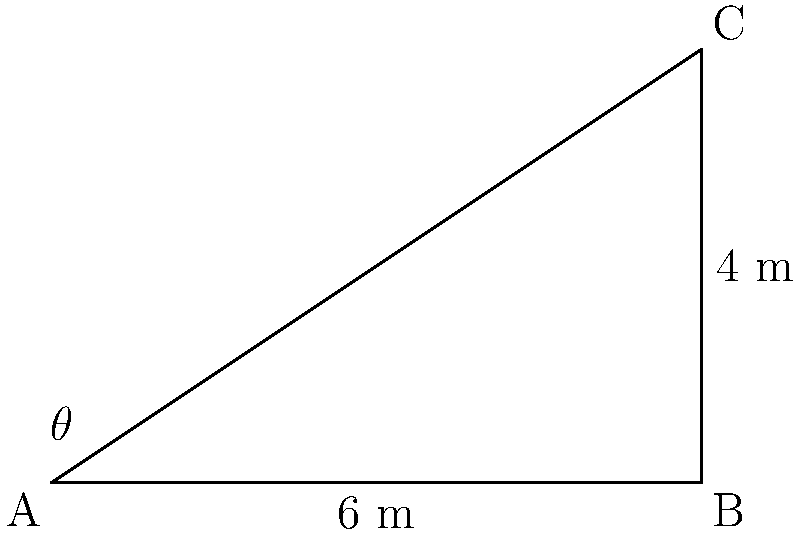At the Lassiter's complex, we're planning a new triangular garden area. The garden will be right-angled, with one side along the hotel wall measuring 6 meters, and another side along the lake shore measuring 4 meters. Using this information, calculate the area of the new garden space. Round your answer to the nearest square meter. Let's approach this step-by-step using trigonometry:

1) We have a right-angled triangle with two known sides:
   - The base (along the hotel wall) is 6 meters
   - The height (along the lake shore) is 4 meters

2) To find the area of a triangle, we use the formula:
   $$ \text{Area} = \frac{1}{2} \times \text{base} \times \text{height} $$

3) Substituting our known values:
   $$ \text{Area} = \frac{1}{2} \times 6 \times 4 $$

4) Calculating:
   $$ \text{Area} = \frac{1}{2} \times 24 = 12 $$

5) Therefore, the area of the new garden space is 12 square meters.

6) As we're asked to round to the nearest square meter, our final answer remains 12 square meters.

This problem relates to the Lassiter's complex, a key location in Neighbours, making it relevant to our shared interest in the show!
Answer: 12 square meters 